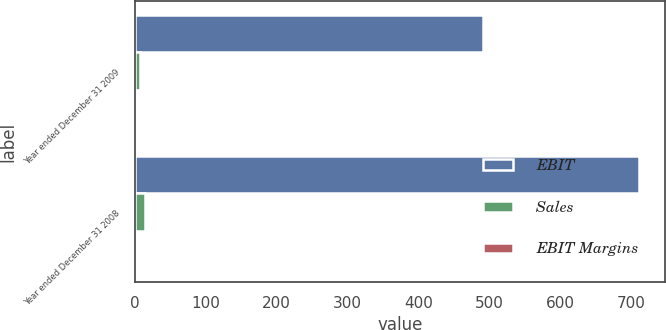<chart> <loc_0><loc_0><loc_500><loc_500><stacked_bar_chart><ecel><fcel>Year ended December 31 2009<fcel>Year ended December 31 2008<nl><fcel>EBIT<fcel>491<fcel>711<nl><fcel>Sales<fcel>8<fcel>14<nl><fcel>EBIT Margins<fcel>1.6<fcel>2<nl></chart> 